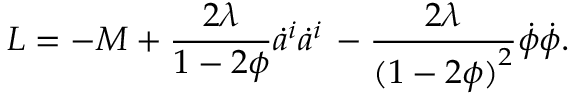<formula> <loc_0><loc_0><loc_500><loc_500>L = - M + { \frac { 2 \lambda } { 1 - 2 \phi } } \dot { a } ^ { i } \dot { a } ^ { i } \, - { \frac { 2 \lambda } { { ( 1 - 2 \phi ) } ^ { 2 } } } \dot { \phi } \dot { \phi } .</formula> 